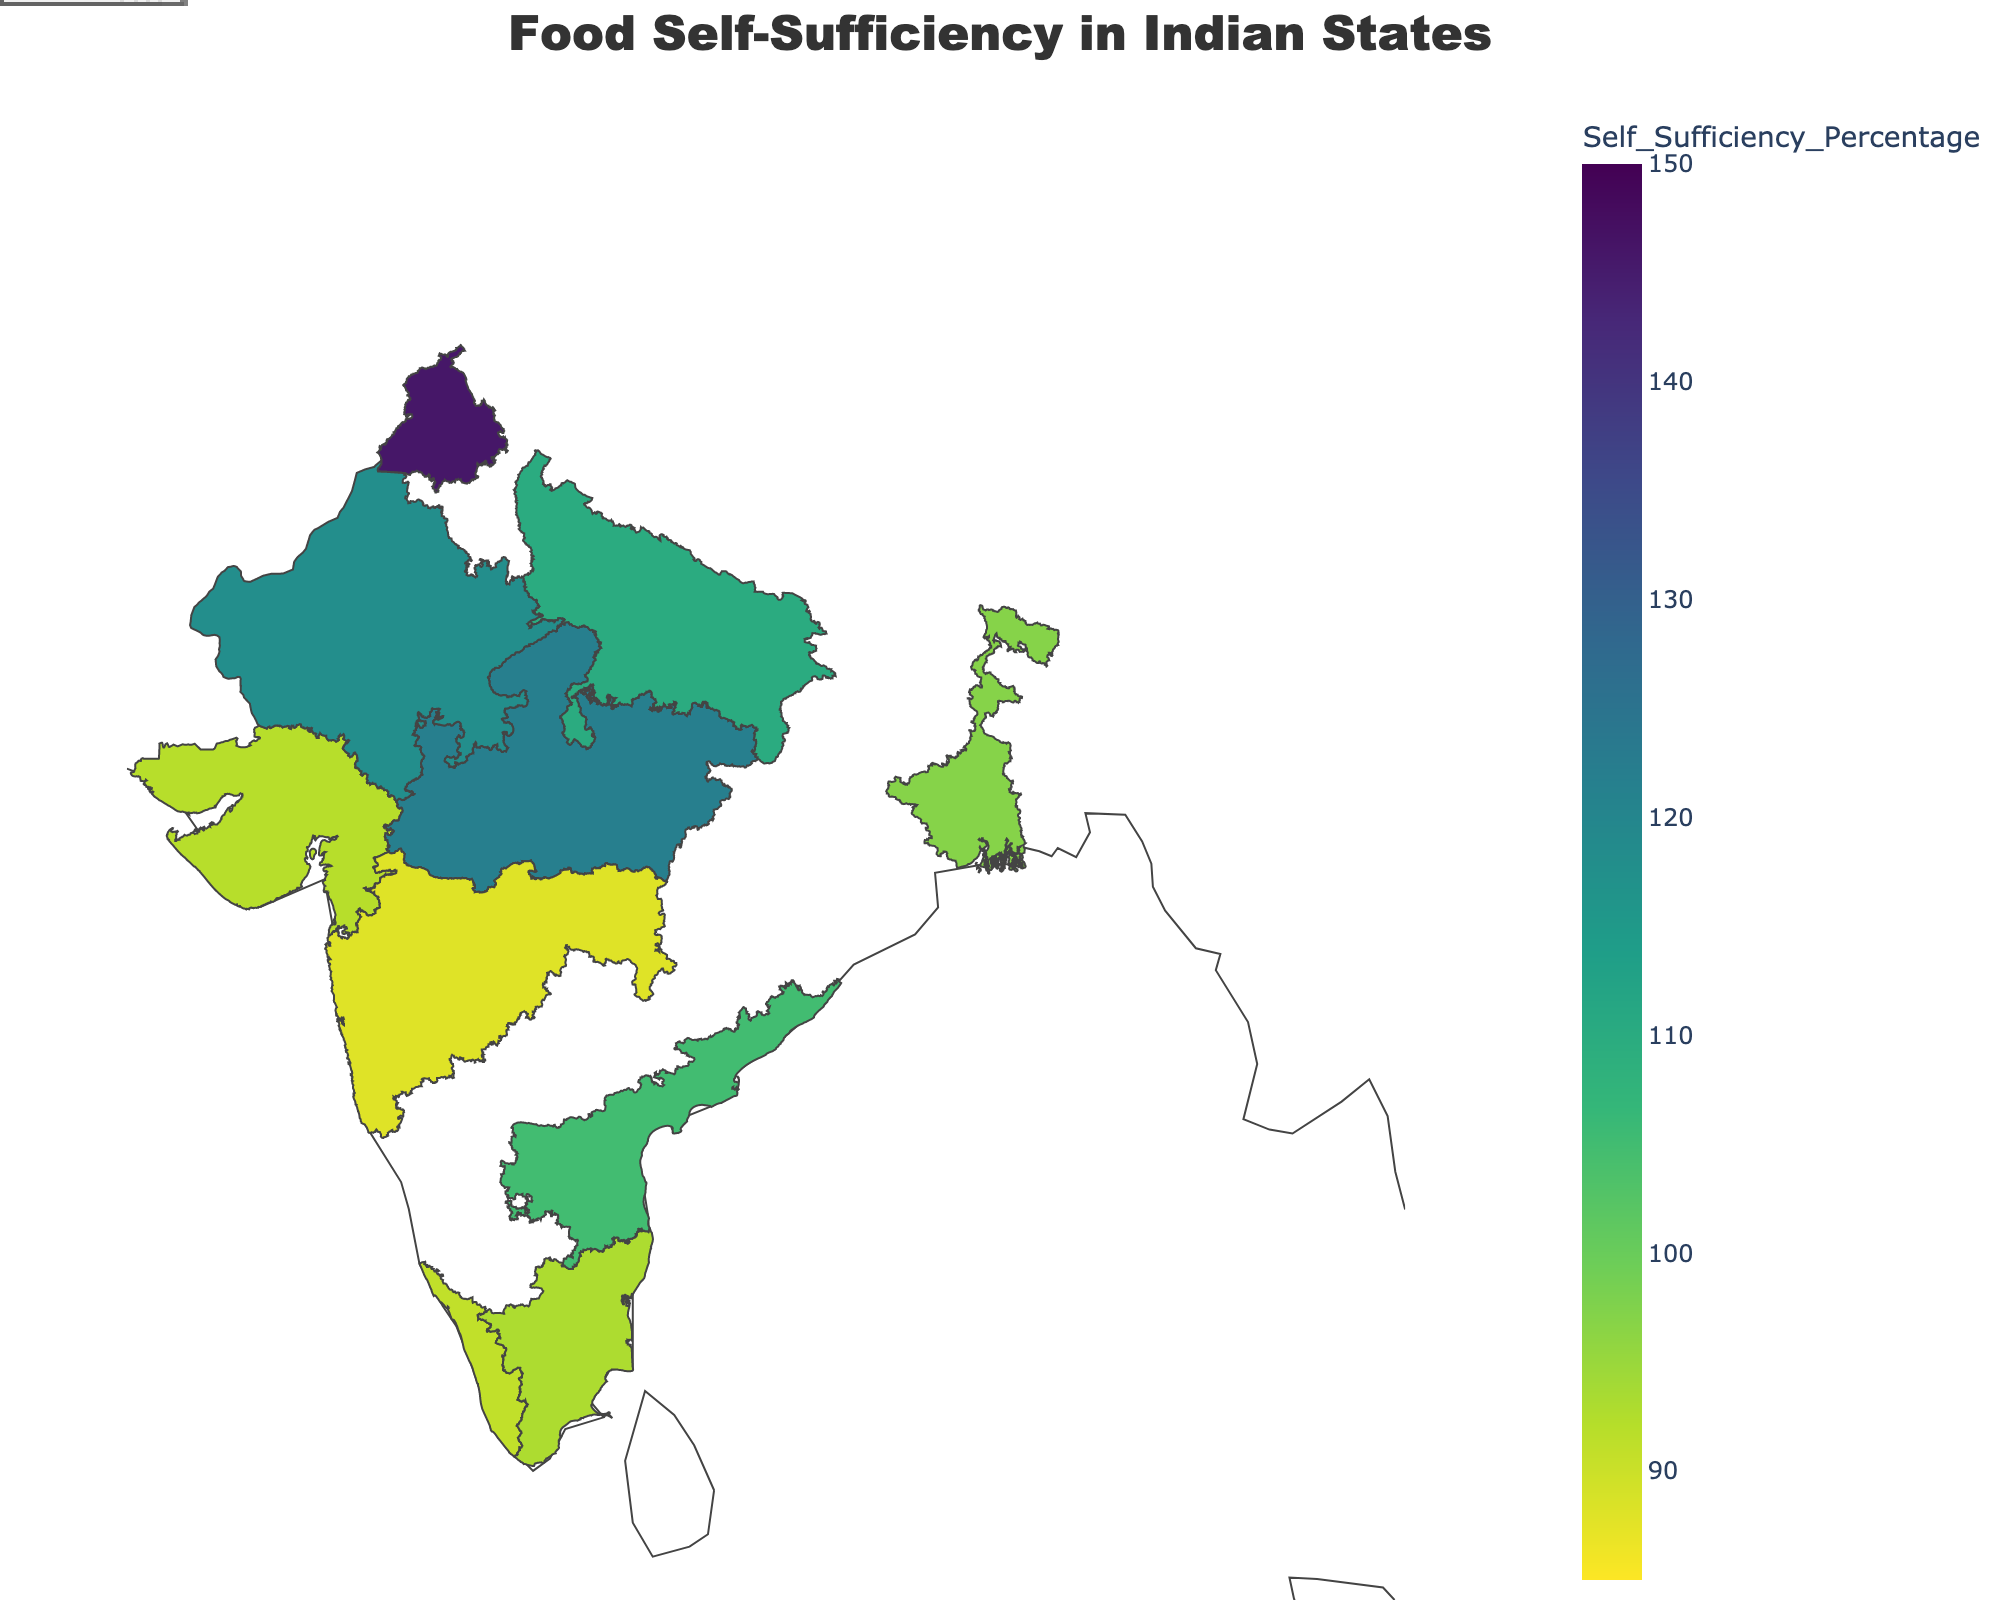what is the title of the figure? The title is located at the top of the figure and reads "Food Self-Sufficiency in Indian States".
Answer: Food Self-Sufficiency in Indian States Which region has the highest self-sufficiency percentage? By referring to the color gradient and the annotations, Punjab has the highest self-sufficiency percentage at 146%.
Answer: Punjab What is the main crop of Kerala? The annotations on the figure indicate each region's main crop. Kerala's annotation shows that the main crop is Rice.
Answer: Rice Which regions have a self-sufficiency percentage greater than 100%? Regions greater than 100% are typically in darker colors. Based on the annotations, Punjab, Madhya Pradesh, Uttar Pradesh, Rajasthan, and Andhra Pradesh have self-sufficiency percentages greater than 100%.
Answer: Punjab, Madhya Pradesh, Uttar Pradesh, Rajasthan, Andhra Pradesh What is the self-sufficiency percentage of Maharashtra, and how does it compare to Andhra Pradesh? From the annotations, Maharashtra has an 88% self-sufficiency rate, while Andhra Pradesh has 105%. Therefore, Maharashtra has a lower self-sufficiency rate than Andhra Pradesh.
Answer: Maharashtra: 88%, Andhra Pradesh: 105% How many regions are mapped in the figure? By counting the annotations for each region, there are 10 regions mapped in the figure.
Answer: 10 Which region has the lowest self-sufficiency percentage, and what is its main crop? Based on the color gradient and annotations, Maharashtra has the lowest self-sufficiency percentage at 88%. The main crop is Jowar.
Answer: Maharashtra, Jowar What is the self-sufficiency percentage for West Bengal, and how much food does it produce locally? The annotations for West Bengal show a self-sufficiency percentage of 97% with local food production at 14,800,000 tons.
Answer: 97%, 14,800,000 tons 